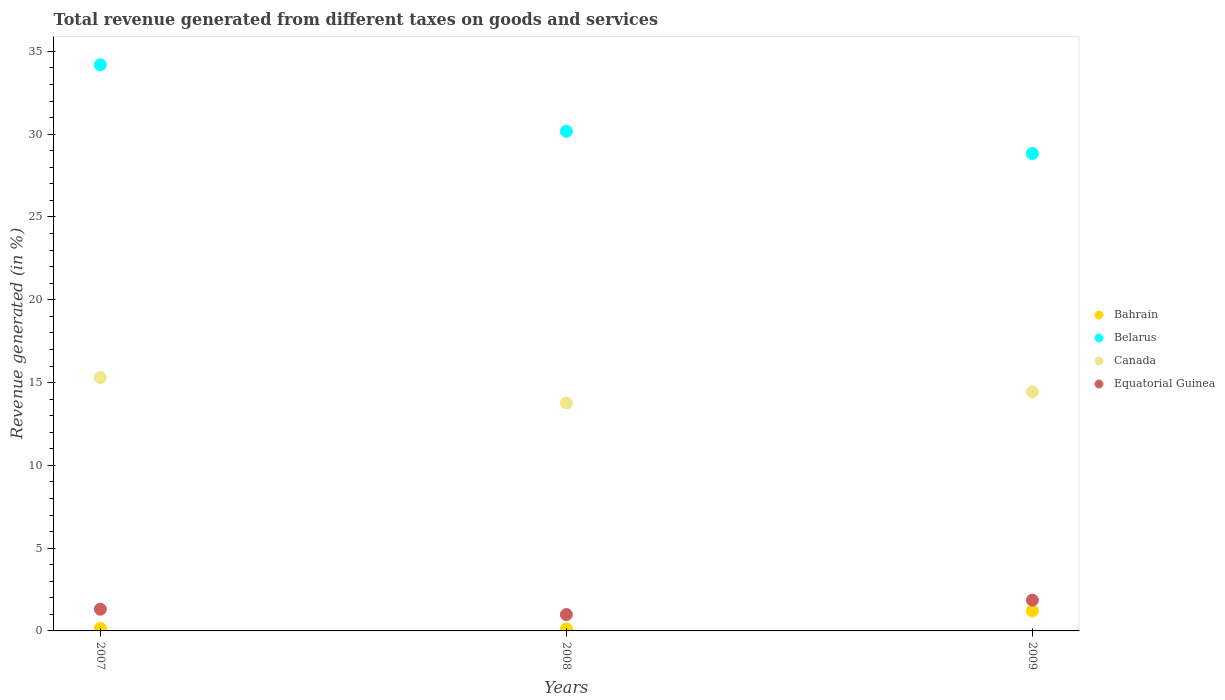Is the number of dotlines equal to the number of legend labels?
Provide a succinct answer. Yes. What is the total revenue generated in Canada in 2007?
Provide a short and direct response. 15.3. Across all years, what is the maximum total revenue generated in Bahrain?
Your answer should be compact. 1.21. Across all years, what is the minimum total revenue generated in Equatorial Guinea?
Your answer should be compact. 0.99. In which year was the total revenue generated in Belarus minimum?
Your response must be concise. 2009. What is the total total revenue generated in Equatorial Guinea in the graph?
Make the answer very short. 4.16. What is the difference between the total revenue generated in Canada in 2008 and that in 2009?
Provide a short and direct response. -0.67. What is the difference between the total revenue generated in Bahrain in 2008 and the total revenue generated in Equatorial Guinea in 2009?
Offer a very short reply. -1.73. What is the average total revenue generated in Bahrain per year?
Your answer should be compact. 0.5. In the year 2009, what is the difference between the total revenue generated in Canada and total revenue generated in Belarus?
Provide a short and direct response. -14.4. In how many years, is the total revenue generated in Canada greater than 2 %?
Provide a succinct answer. 3. What is the ratio of the total revenue generated in Belarus in 2007 to that in 2009?
Provide a succinct answer. 1.19. Is the total revenue generated in Belarus in 2008 less than that in 2009?
Give a very brief answer. No. What is the difference between the highest and the second highest total revenue generated in Canada?
Give a very brief answer. 0.87. What is the difference between the highest and the lowest total revenue generated in Canada?
Offer a terse response. 1.53. Is it the case that in every year, the sum of the total revenue generated in Bahrain and total revenue generated in Equatorial Guinea  is greater than the sum of total revenue generated in Belarus and total revenue generated in Canada?
Your response must be concise. No. Does the total revenue generated in Canada monotonically increase over the years?
Your response must be concise. No. Is the total revenue generated in Canada strictly greater than the total revenue generated in Bahrain over the years?
Offer a very short reply. Yes. How many dotlines are there?
Your answer should be compact. 4. How many years are there in the graph?
Make the answer very short. 3. What is the difference between two consecutive major ticks on the Y-axis?
Give a very brief answer. 5. Are the values on the major ticks of Y-axis written in scientific E-notation?
Your answer should be compact. No. How many legend labels are there?
Offer a terse response. 4. How are the legend labels stacked?
Your response must be concise. Vertical. What is the title of the graph?
Provide a succinct answer. Total revenue generated from different taxes on goods and services. Does "Middle income" appear as one of the legend labels in the graph?
Provide a succinct answer. No. What is the label or title of the X-axis?
Provide a succinct answer. Years. What is the label or title of the Y-axis?
Offer a terse response. Revenue generated (in %). What is the Revenue generated (in %) of Bahrain in 2007?
Give a very brief answer. 0.15. What is the Revenue generated (in %) in Belarus in 2007?
Keep it short and to the point. 34.19. What is the Revenue generated (in %) in Canada in 2007?
Make the answer very short. 15.3. What is the Revenue generated (in %) of Equatorial Guinea in 2007?
Your answer should be very brief. 1.31. What is the Revenue generated (in %) in Bahrain in 2008?
Offer a terse response. 0.12. What is the Revenue generated (in %) in Belarus in 2008?
Give a very brief answer. 30.17. What is the Revenue generated (in %) of Canada in 2008?
Offer a very short reply. 13.77. What is the Revenue generated (in %) of Equatorial Guinea in 2008?
Your response must be concise. 0.99. What is the Revenue generated (in %) in Bahrain in 2009?
Offer a very short reply. 1.21. What is the Revenue generated (in %) of Belarus in 2009?
Your answer should be very brief. 28.84. What is the Revenue generated (in %) in Canada in 2009?
Provide a succinct answer. 14.44. What is the Revenue generated (in %) in Equatorial Guinea in 2009?
Your answer should be very brief. 1.86. Across all years, what is the maximum Revenue generated (in %) of Bahrain?
Offer a terse response. 1.21. Across all years, what is the maximum Revenue generated (in %) in Belarus?
Give a very brief answer. 34.19. Across all years, what is the maximum Revenue generated (in %) of Canada?
Your answer should be compact. 15.3. Across all years, what is the maximum Revenue generated (in %) of Equatorial Guinea?
Keep it short and to the point. 1.86. Across all years, what is the minimum Revenue generated (in %) of Bahrain?
Keep it short and to the point. 0.12. Across all years, what is the minimum Revenue generated (in %) of Belarus?
Your answer should be very brief. 28.84. Across all years, what is the minimum Revenue generated (in %) of Canada?
Your answer should be very brief. 13.77. Across all years, what is the minimum Revenue generated (in %) of Equatorial Guinea?
Offer a very short reply. 0.99. What is the total Revenue generated (in %) of Bahrain in the graph?
Provide a succinct answer. 1.49. What is the total Revenue generated (in %) in Belarus in the graph?
Keep it short and to the point. 93.2. What is the total Revenue generated (in %) in Canada in the graph?
Offer a very short reply. 43.51. What is the total Revenue generated (in %) of Equatorial Guinea in the graph?
Make the answer very short. 4.16. What is the difference between the Revenue generated (in %) of Bahrain in 2007 and that in 2008?
Your response must be concise. 0.03. What is the difference between the Revenue generated (in %) in Belarus in 2007 and that in 2008?
Your response must be concise. 4.02. What is the difference between the Revenue generated (in %) of Canada in 2007 and that in 2008?
Offer a very short reply. 1.53. What is the difference between the Revenue generated (in %) of Equatorial Guinea in 2007 and that in 2008?
Provide a short and direct response. 0.32. What is the difference between the Revenue generated (in %) of Bahrain in 2007 and that in 2009?
Offer a terse response. -1.06. What is the difference between the Revenue generated (in %) of Belarus in 2007 and that in 2009?
Provide a succinct answer. 5.36. What is the difference between the Revenue generated (in %) in Canada in 2007 and that in 2009?
Provide a succinct answer. 0.87. What is the difference between the Revenue generated (in %) in Equatorial Guinea in 2007 and that in 2009?
Give a very brief answer. -0.55. What is the difference between the Revenue generated (in %) of Bahrain in 2008 and that in 2009?
Your response must be concise. -1.09. What is the difference between the Revenue generated (in %) in Belarus in 2008 and that in 2009?
Make the answer very short. 1.34. What is the difference between the Revenue generated (in %) of Canada in 2008 and that in 2009?
Offer a very short reply. -0.67. What is the difference between the Revenue generated (in %) in Equatorial Guinea in 2008 and that in 2009?
Make the answer very short. -0.87. What is the difference between the Revenue generated (in %) in Bahrain in 2007 and the Revenue generated (in %) in Belarus in 2008?
Provide a succinct answer. -30.02. What is the difference between the Revenue generated (in %) in Bahrain in 2007 and the Revenue generated (in %) in Canada in 2008?
Give a very brief answer. -13.61. What is the difference between the Revenue generated (in %) of Bahrain in 2007 and the Revenue generated (in %) of Equatorial Guinea in 2008?
Provide a succinct answer. -0.84. What is the difference between the Revenue generated (in %) in Belarus in 2007 and the Revenue generated (in %) in Canada in 2008?
Provide a succinct answer. 20.43. What is the difference between the Revenue generated (in %) of Belarus in 2007 and the Revenue generated (in %) of Equatorial Guinea in 2008?
Your answer should be compact. 33.2. What is the difference between the Revenue generated (in %) of Canada in 2007 and the Revenue generated (in %) of Equatorial Guinea in 2008?
Your response must be concise. 14.31. What is the difference between the Revenue generated (in %) of Bahrain in 2007 and the Revenue generated (in %) of Belarus in 2009?
Your response must be concise. -28.68. What is the difference between the Revenue generated (in %) in Bahrain in 2007 and the Revenue generated (in %) in Canada in 2009?
Ensure brevity in your answer.  -14.28. What is the difference between the Revenue generated (in %) of Bahrain in 2007 and the Revenue generated (in %) of Equatorial Guinea in 2009?
Keep it short and to the point. -1.7. What is the difference between the Revenue generated (in %) in Belarus in 2007 and the Revenue generated (in %) in Canada in 2009?
Give a very brief answer. 19.76. What is the difference between the Revenue generated (in %) of Belarus in 2007 and the Revenue generated (in %) of Equatorial Guinea in 2009?
Offer a terse response. 32.34. What is the difference between the Revenue generated (in %) of Canada in 2007 and the Revenue generated (in %) of Equatorial Guinea in 2009?
Provide a short and direct response. 13.44. What is the difference between the Revenue generated (in %) in Bahrain in 2008 and the Revenue generated (in %) in Belarus in 2009?
Offer a very short reply. -28.71. What is the difference between the Revenue generated (in %) of Bahrain in 2008 and the Revenue generated (in %) of Canada in 2009?
Make the answer very short. -14.31. What is the difference between the Revenue generated (in %) in Bahrain in 2008 and the Revenue generated (in %) in Equatorial Guinea in 2009?
Offer a terse response. -1.73. What is the difference between the Revenue generated (in %) of Belarus in 2008 and the Revenue generated (in %) of Canada in 2009?
Ensure brevity in your answer.  15.74. What is the difference between the Revenue generated (in %) in Belarus in 2008 and the Revenue generated (in %) in Equatorial Guinea in 2009?
Give a very brief answer. 28.32. What is the difference between the Revenue generated (in %) in Canada in 2008 and the Revenue generated (in %) in Equatorial Guinea in 2009?
Your answer should be compact. 11.91. What is the average Revenue generated (in %) in Bahrain per year?
Your response must be concise. 0.5. What is the average Revenue generated (in %) in Belarus per year?
Provide a short and direct response. 31.07. What is the average Revenue generated (in %) in Canada per year?
Provide a succinct answer. 14.5. What is the average Revenue generated (in %) in Equatorial Guinea per year?
Ensure brevity in your answer.  1.39. In the year 2007, what is the difference between the Revenue generated (in %) in Bahrain and Revenue generated (in %) in Belarus?
Offer a terse response. -34.04. In the year 2007, what is the difference between the Revenue generated (in %) of Bahrain and Revenue generated (in %) of Canada?
Your answer should be compact. -15.15. In the year 2007, what is the difference between the Revenue generated (in %) of Bahrain and Revenue generated (in %) of Equatorial Guinea?
Your answer should be very brief. -1.16. In the year 2007, what is the difference between the Revenue generated (in %) in Belarus and Revenue generated (in %) in Canada?
Ensure brevity in your answer.  18.89. In the year 2007, what is the difference between the Revenue generated (in %) of Belarus and Revenue generated (in %) of Equatorial Guinea?
Your response must be concise. 32.88. In the year 2007, what is the difference between the Revenue generated (in %) in Canada and Revenue generated (in %) in Equatorial Guinea?
Provide a short and direct response. 13.99. In the year 2008, what is the difference between the Revenue generated (in %) in Bahrain and Revenue generated (in %) in Belarus?
Give a very brief answer. -30.05. In the year 2008, what is the difference between the Revenue generated (in %) in Bahrain and Revenue generated (in %) in Canada?
Give a very brief answer. -13.64. In the year 2008, what is the difference between the Revenue generated (in %) of Bahrain and Revenue generated (in %) of Equatorial Guinea?
Provide a succinct answer. -0.87. In the year 2008, what is the difference between the Revenue generated (in %) of Belarus and Revenue generated (in %) of Canada?
Make the answer very short. 16.41. In the year 2008, what is the difference between the Revenue generated (in %) of Belarus and Revenue generated (in %) of Equatorial Guinea?
Provide a succinct answer. 29.18. In the year 2008, what is the difference between the Revenue generated (in %) of Canada and Revenue generated (in %) of Equatorial Guinea?
Your answer should be very brief. 12.78. In the year 2009, what is the difference between the Revenue generated (in %) in Bahrain and Revenue generated (in %) in Belarus?
Give a very brief answer. -27.62. In the year 2009, what is the difference between the Revenue generated (in %) in Bahrain and Revenue generated (in %) in Canada?
Offer a very short reply. -13.22. In the year 2009, what is the difference between the Revenue generated (in %) of Bahrain and Revenue generated (in %) of Equatorial Guinea?
Ensure brevity in your answer.  -0.65. In the year 2009, what is the difference between the Revenue generated (in %) of Belarus and Revenue generated (in %) of Canada?
Your answer should be compact. 14.4. In the year 2009, what is the difference between the Revenue generated (in %) of Belarus and Revenue generated (in %) of Equatorial Guinea?
Keep it short and to the point. 26.98. In the year 2009, what is the difference between the Revenue generated (in %) in Canada and Revenue generated (in %) in Equatorial Guinea?
Your answer should be compact. 12.58. What is the ratio of the Revenue generated (in %) of Bahrain in 2007 to that in 2008?
Offer a terse response. 1.24. What is the ratio of the Revenue generated (in %) in Belarus in 2007 to that in 2008?
Ensure brevity in your answer.  1.13. What is the ratio of the Revenue generated (in %) in Canada in 2007 to that in 2008?
Provide a short and direct response. 1.11. What is the ratio of the Revenue generated (in %) of Equatorial Guinea in 2007 to that in 2008?
Give a very brief answer. 1.32. What is the ratio of the Revenue generated (in %) of Bahrain in 2007 to that in 2009?
Ensure brevity in your answer.  0.13. What is the ratio of the Revenue generated (in %) of Belarus in 2007 to that in 2009?
Offer a terse response. 1.19. What is the ratio of the Revenue generated (in %) of Canada in 2007 to that in 2009?
Make the answer very short. 1.06. What is the ratio of the Revenue generated (in %) of Equatorial Guinea in 2007 to that in 2009?
Your answer should be very brief. 0.71. What is the ratio of the Revenue generated (in %) in Bahrain in 2008 to that in 2009?
Your answer should be very brief. 0.1. What is the ratio of the Revenue generated (in %) of Belarus in 2008 to that in 2009?
Your answer should be compact. 1.05. What is the ratio of the Revenue generated (in %) in Canada in 2008 to that in 2009?
Keep it short and to the point. 0.95. What is the ratio of the Revenue generated (in %) in Equatorial Guinea in 2008 to that in 2009?
Ensure brevity in your answer.  0.53. What is the difference between the highest and the second highest Revenue generated (in %) of Bahrain?
Provide a succinct answer. 1.06. What is the difference between the highest and the second highest Revenue generated (in %) in Belarus?
Offer a very short reply. 4.02. What is the difference between the highest and the second highest Revenue generated (in %) in Canada?
Your response must be concise. 0.87. What is the difference between the highest and the second highest Revenue generated (in %) of Equatorial Guinea?
Offer a very short reply. 0.55. What is the difference between the highest and the lowest Revenue generated (in %) in Bahrain?
Make the answer very short. 1.09. What is the difference between the highest and the lowest Revenue generated (in %) in Belarus?
Your response must be concise. 5.36. What is the difference between the highest and the lowest Revenue generated (in %) in Canada?
Provide a succinct answer. 1.53. What is the difference between the highest and the lowest Revenue generated (in %) in Equatorial Guinea?
Your answer should be compact. 0.87. 